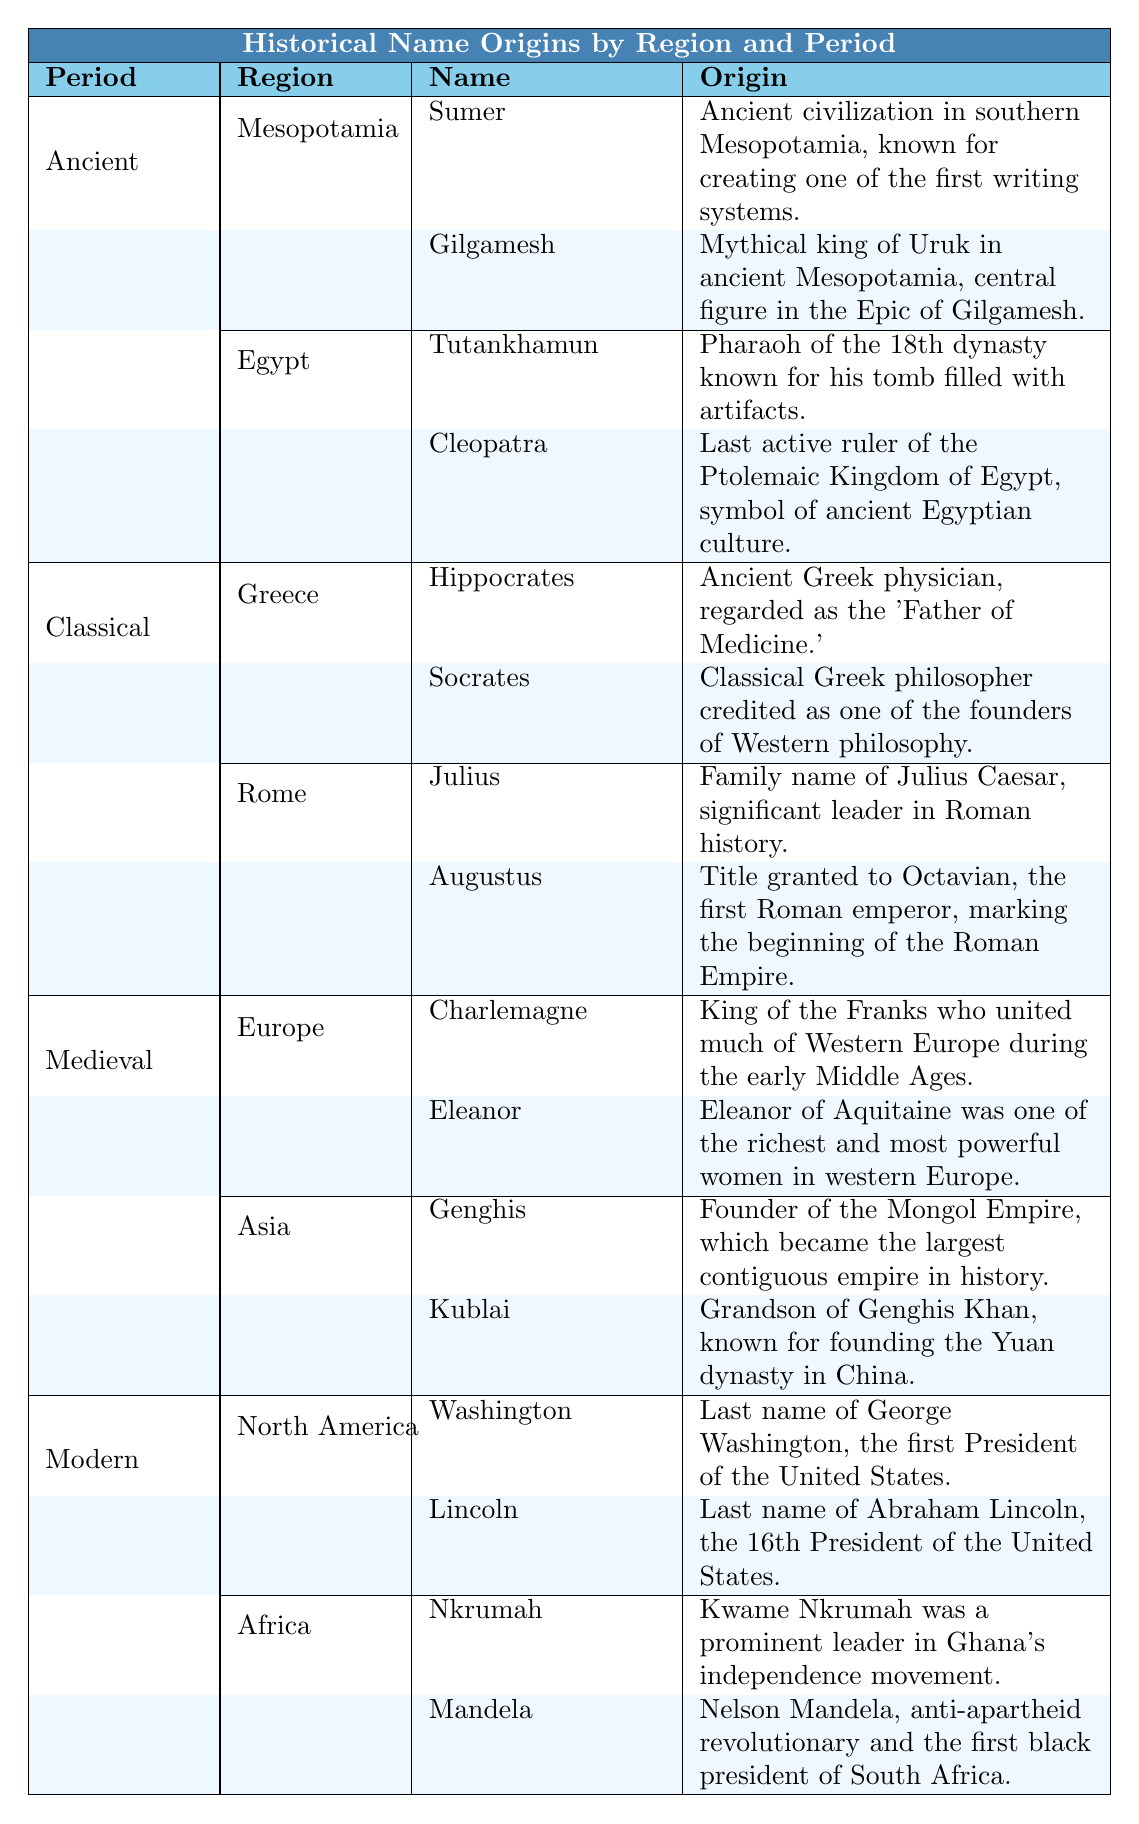What are the names listed under the Ancient Mesopotamia region? The table shows that there are two names listed under Ancient Mesopotamia: "Sumer" and "Gilgamesh."
Answer: Sumer, Gilgamesh Who is known as the "Father of Medicine"? The table indicates that Hippocrates is regarded as the "Father of Medicine" under the Greece region of the Classical period.
Answer: Hippocrates Which name corresponds to the last active ruler of the Ptolemaic Kingdom of Egypt? According to the table, Cleopatra is listed as the last active ruler of the Ptolemaic Kingdom of Egypt.
Answer: Cleopatra List all the names associated with the Medieval Europe region. The table shows two names associated with Medieval Europe: "Charlemagne" and "Eleanor."
Answer: Charlemagne, Eleanor Is "Augustus" associated with the region of Greece? The table indicates that Augustus is listed under the region of Rome, not Greece.
Answer: No What is the origin of the name "Nkrumah"? The origin description for Nkrumah in the African section states that he was a prominent leader in Ghana's independence movement.
Answer: Prominent leader in Ghana's independence movement Which period features "Genghis" and what is his significance? "Genghis" is listed under the Medieval period, specifically in the Asia region, and he is noted as the founder of the Mongol Empire.
Answer: Medieval, founder of the Mongol Empire How many historical names are listed for the region of North America in the Modern period? There are two names listed for North America: "Washington" and "Lincoln," so we can conclude there are two names.
Answer: 2 Which period has the name "Charlemagne" associated with the Europe region? The table shows that Charlemagne is associated with the Medieval period, specifically in the Europe region.
Answer: Medieval Which name in the table has an origin related to the first black president of South Africa? The table indicates that "Mandela" has an origin describing Nelson Mandela, who was the first black president of South Africa.
Answer: Mandela In the Classical period, which name is connected to a significant leader in Roman history? The table states that the name "Julius" is connected to Julius Caesar, a significant leader in Roman history.
Answer: Julius How many names are there in total for the Ancient period? There are four names listed under the Ancient period: two in Mesopotamia (Sumer, Gilgamesh) and two in Egypt (Tutankhamun, Cleopatra), giving a total of four.
Answer: 4 What does the name "Kublai" represent and in which region does it belong? Kublai is associated with Asia in the Medieval period and is known for founding the Yuan dynasty in China.
Answer: Kublai, Asia, founder of Yuan dynasty Does the name "Socrates" appear in the Medieval period? The table indicates that Socrates does not appear in the Medieval period; instead, he is listed in the Classical period under Greece.
Answer: No Which period contains the names "Washington" and "Lincoln"? The table shows that both names are listed under the Modern period in the North America region.
Answer: Modern Identify one figure from the Medieval Asia region and describe his significance. The table indicates that "Genghis" is a figure from Medieval Asia, significant as the founder of the Mongol Empire.
Answer: Genghis, founder of Mongol Empire 